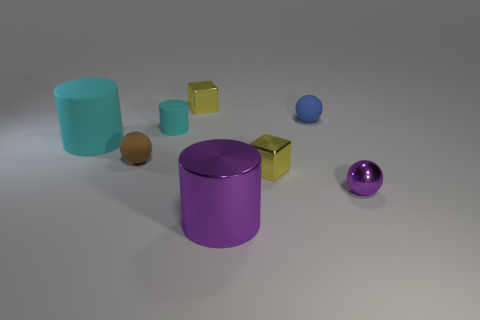Subtract all cyan cylinders. How many cylinders are left? 1 Add 1 small purple metallic things. How many objects exist? 9 Subtract all blue spheres. How many spheres are left? 2 Subtract all cubes. How many objects are left? 6 Subtract all tiny rubber objects. Subtract all tiny green metallic cylinders. How many objects are left? 5 Add 3 big purple metallic cylinders. How many big purple metallic cylinders are left? 4 Add 1 matte balls. How many matte balls exist? 3 Subtract 0 red balls. How many objects are left? 8 Subtract 2 cylinders. How many cylinders are left? 1 Subtract all green balls. Subtract all cyan cylinders. How many balls are left? 3 